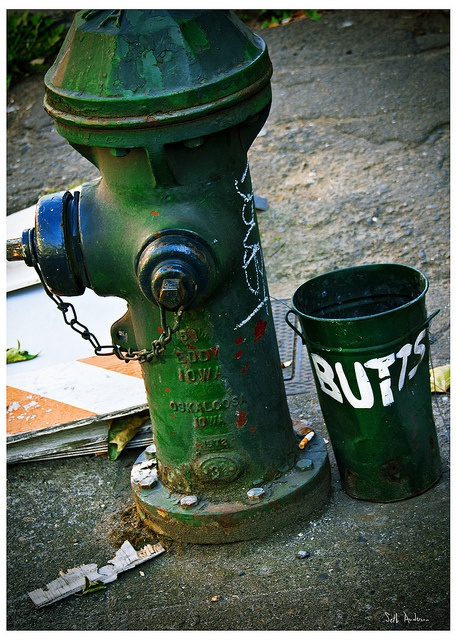Describe the objects in this image and their specific colors. I can see a fire hydrant in white, black, darkgreen, and teal tones in this image. 